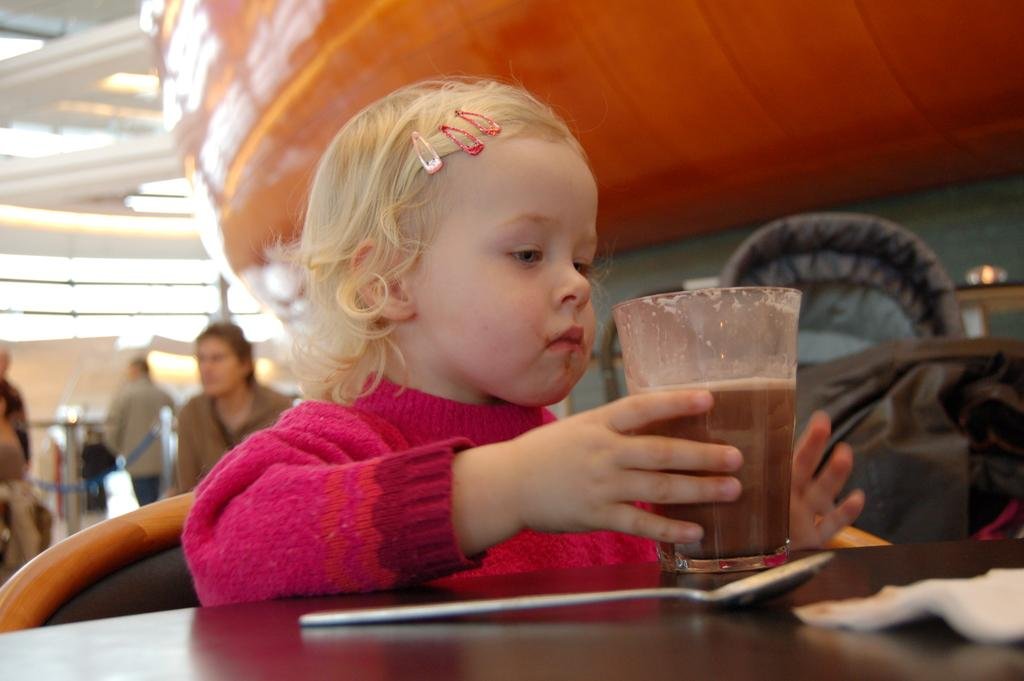Who is the main subject in the image? There is a girl in the image. What is the girl doing in the image? The girl is sitting on a chair. Where is the girl positioned in relation to the table? The girl is in front of a table. What can be seen on the table in the image? There is a glass placed on the table. Can you describe the background of the image? The background of the image is blurred. What type of toy is the girl playing with in the image? There is no toy present in the image; the girl is sitting on a chair in front of a table with a glass on it. 